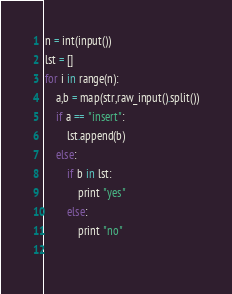Convert code to text. <code><loc_0><loc_0><loc_500><loc_500><_Python_>n = int(input())
lst = []
for i in range(n):
    a,b = map(str,raw_input().split())
    if a == "insert":
        lst.append(b)
    else:
        if b in lst:
            print "yes"
        else:
            print "no"
    </code> 